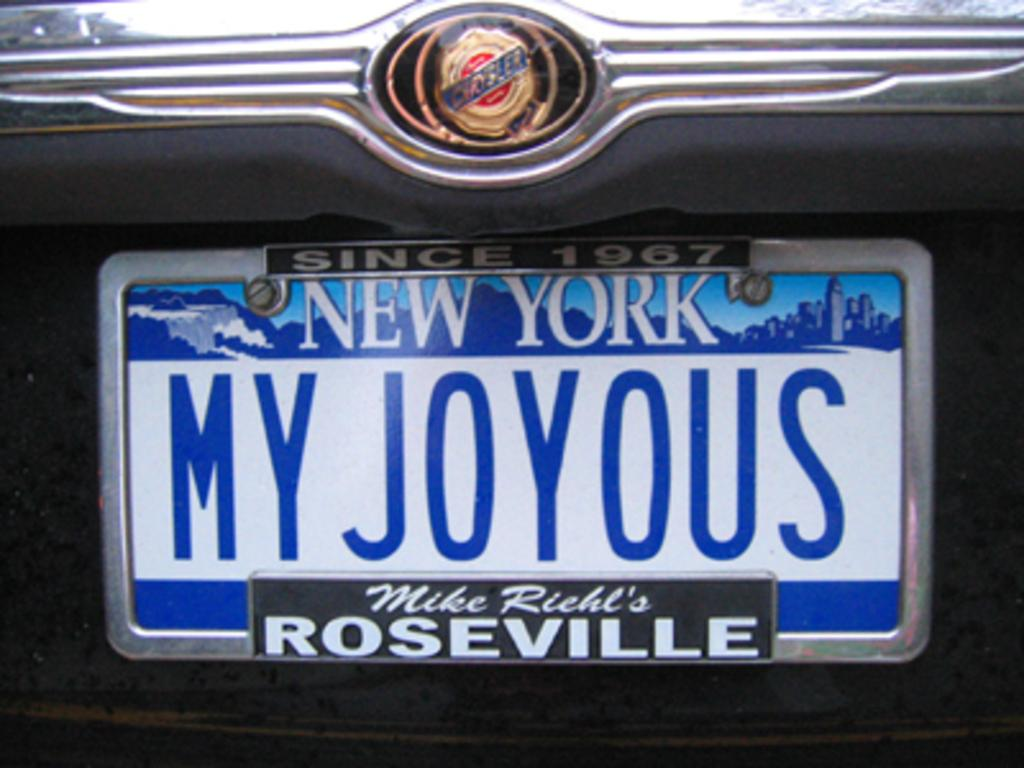<image>
Create a compact narrative representing the image presented. A license plate for New York says MY JOYOUS. 